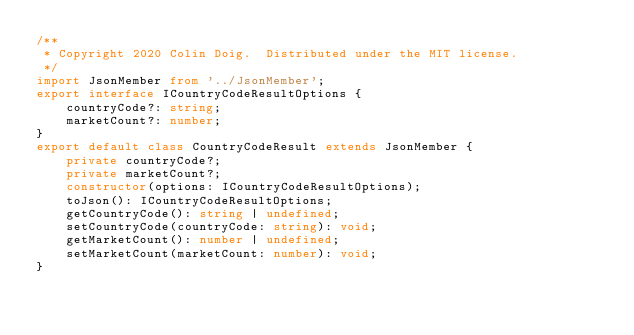<code> <loc_0><loc_0><loc_500><loc_500><_TypeScript_>/**
 * Copyright 2020 Colin Doig.  Distributed under the MIT license.
 */
import JsonMember from '../JsonMember';
export interface ICountryCodeResultOptions {
    countryCode?: string;
    marketCount?: number;
}
export default class CountryCodeResult extends JsonMember {
    private countryCode?;
    private marketCount?;
    constructor(options: ICountryCodeResultOptions);
    toJson(): ICountryCodeResultOptions;
    getCountryCode(): string | undefined;
    setCountryCode(countryCode: string): void;
    getMarketCount(): number | undefined;
    setMarketCount(marketCount: number): void;
}
</code> 